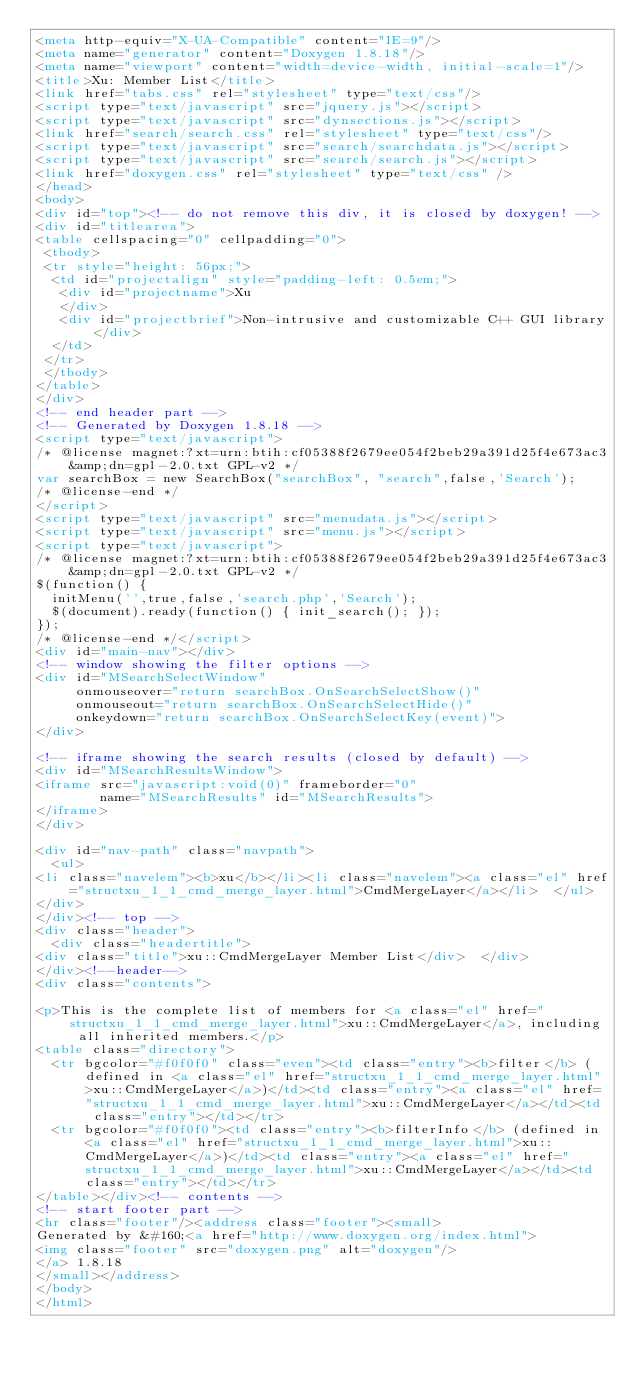Convert code to text. <code><loc_0><loc_0><loc_500><loc_500><_HTML_><meta http-equiv="X-UA-Compatible" content="IE=9"/>
<meta name="generator" content="Doxygen 1.8.18"/>
<meta name="viewport" content="width=device-width, initial-scale=1"/>
<title>Xu: Member List</title>
<link href="tabs.css" rel="stylesheet" type="text/css"/>
<script type="text/javascript" src="jquery.js"></script>
<script type="text/javascript" src="dynsections.js"></script>
<link href="search/search.css" rel="stylesheet" type="text/css"/>
<script type="text/javascript" src="search/searchdata.js"></script>
<script type="text/javascript" src="search/search.js"></script>
<link href="doxygen.css" rel="stylesheet" type="text/css" />
</head>
<body>
<div id="top"><!-- do not remove this div, it is closed by doxygen! -->
<div id="titlearea">
<table cellspacing="0" cellpadding="0">
 <tbody>
 <tr style="height: 56px;">
  <td id="projectalign" style="padding-left: 0.5em;">
   <div id="projectname">Xu
   </div>
   <div id="projectbrief">Non-intrusive and customizable C++ GUI library</div>
  </td>
 </tr>
 </tbody>
</table>
</div>
<!-- end header part -->
<!-- Generated by Doxygen 1.8.18 -->
<script type="text/javascript">
/* @license magnet:?xt=urn:btih:cf05388f2679ee054f2beb29a391d25f4e673ac3&amp;dn=gpl-2.0.txt GPL-v2 */
var searchBox = new SearchBox("searchBox", "search",false,'Search');
/* @license-end */
</script>
<script type="text/javascript" src="menudata.js"></script>
<script type="text/javascript" src="menu.js"></script>
<script type="text/javascript">
/* @license magnet:?xt=urn:btih:cf05388f2679ee054f2beb29a391d25f4e673ac3&amp;dn=gpl-2.0.txt GPL-v2 */
$(function() {
  initMenu('',true,false,'search.php','Search');
  $(document).ready(function() { init_search(); });
});
/* @license-end */</script>
<div id="main-nav"></div>
<!-- window showing the filter options -->
<div id="MSearchSelectWindow"
     onmouseover="return searchBox.OnSearchSelectShow()"
     onmouseout="return searchBox.OnSearchSelectHide()"
     onkeydown="return searchBox.OnSearchSelectKey(event)">
</div>

<!-- iframe showing the search results (closed by default) -->
<div id="MSearchResultsWindow">
<iframe src="javascript:void(0)" frameborder="0" 
        name="MSearchResults" id="MSearchResults">
</iframe>
</div>

<div id="nav-path" class="navpath">
  <ul>
<li class="navelem"><b>xu</b></li><li class="navelem"><a class="el" href="structxu_1_1_cmd_merge_layer.html">CmdMergeLayer</a></li>  </ul>
</div>
</div><!-- top -->
<div class="header">
  <div class="headertitle">
<div class="title">xu::CmdMergeLayer Member List</div>  </div>
</div><!--header-->
<div class="contents">

<p>This is the complete list of members for <a class="el" href="structxu_1_1_cmd_merge_layer.html">xu::CmdMergeLayer</a>, including all inherited members.</p>
<table class="directory">
  <tr bgcolor="#f0f0f0" class="even"><td class="entry"><b>filter</b> (defined in <a class="el" href="structxu_1_1_cmd_merge_layer.html">xu::CmdMergeLayer</a>)</td><td class="entry"><a class="el" href="structxu_1_1_cmd_merge_layer.html">xu::CmdMergeLayer</a></td><td class="entry"></td></tr>
  <tr bgcolor="#f0f0f0"><td class="entry"><b>filterInfo</b> (defined in <a class="el" href="structxu_1_1_cmd_merge_layer.html">xu::CmdMergeLayer</a>)</td><td class="entry"><a class="el" href="structxu_1_1_cmd_merge_layer.html">xu::CmdMergeLayer</a></td><td class="entry"></td></tr>
</table></div><!-- contents -->
<!-- start footer part -->
<hr class="footer"/><address class="footer"><small>
Generated by &#160;<a href="http://www.doxygen.org/index.html">
<img class="footer" src="doxygen.png" alt="doxygen"/>
</a> 1.8.18
</small></address>
</body>
</html>
</code> 